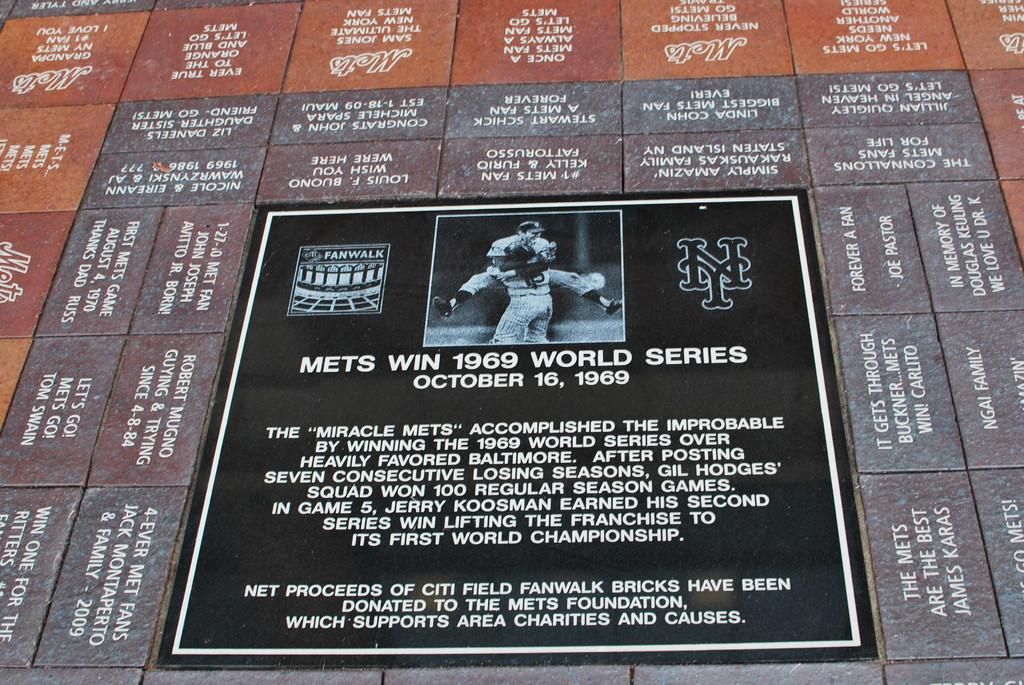Provide a one-sentence caption for the provided image. A flat statue of the mets win the 1969 wold series. 